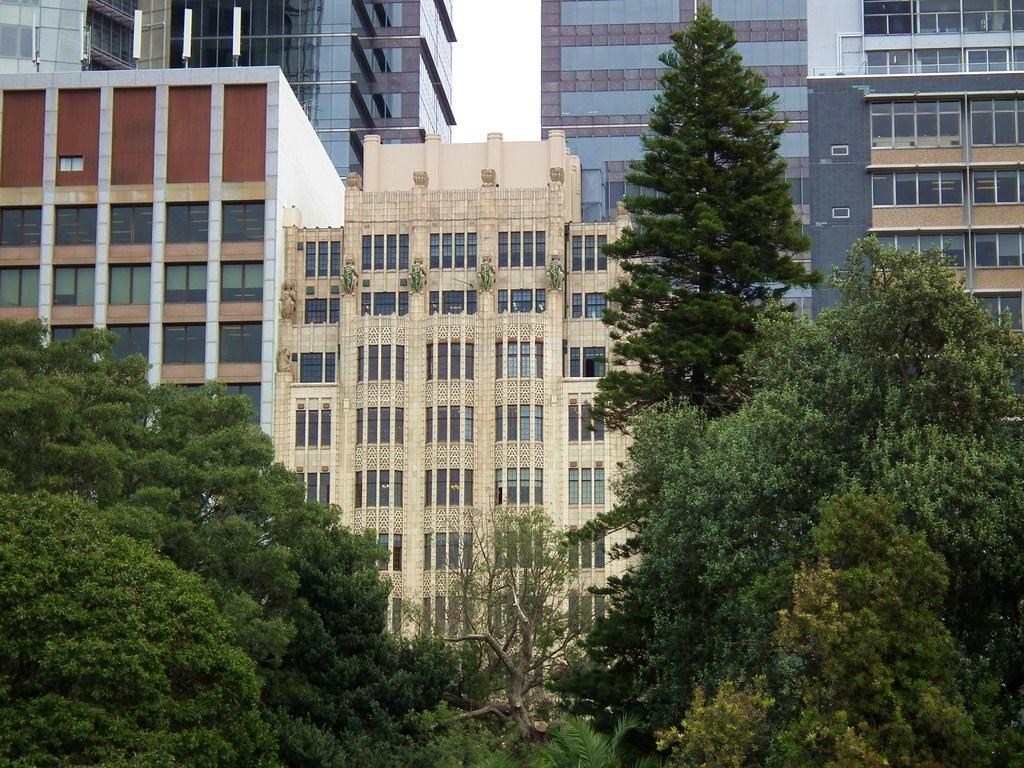How would you summarize this image in a sentence or two? In the background we can see the sky, buildings and windows. At the bottom portion of the picture we can see the trees. 